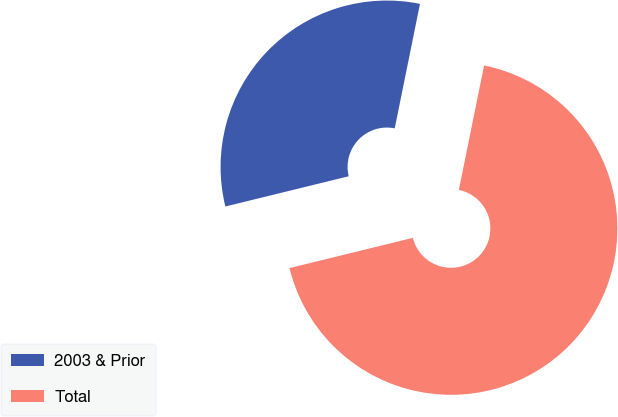Convert chart. <chart><loc_0><loc_0><loc_500><loc_500><pie_chart><fcel>2003 & Prior<fcel>Total<nl><fcel>32.01%<fcel>67.99%<nl></chart> 